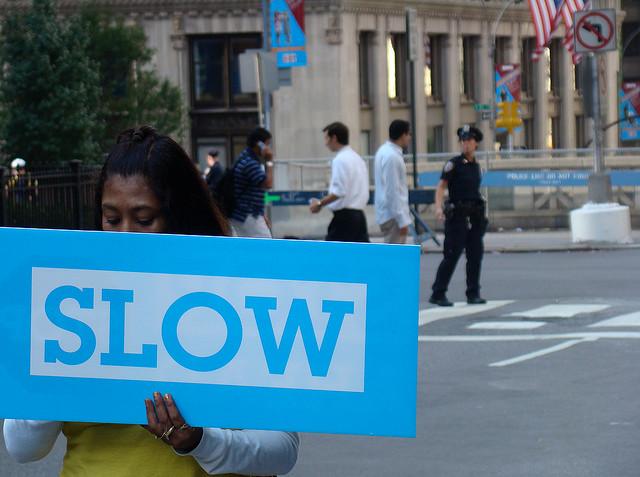How many vowels in the sign she's holding?
Concise answer only. 1. How many police officers are there?
Write a very short answer. 1. Why is the woman holding the sign?
Be succinct. To slow people down. 